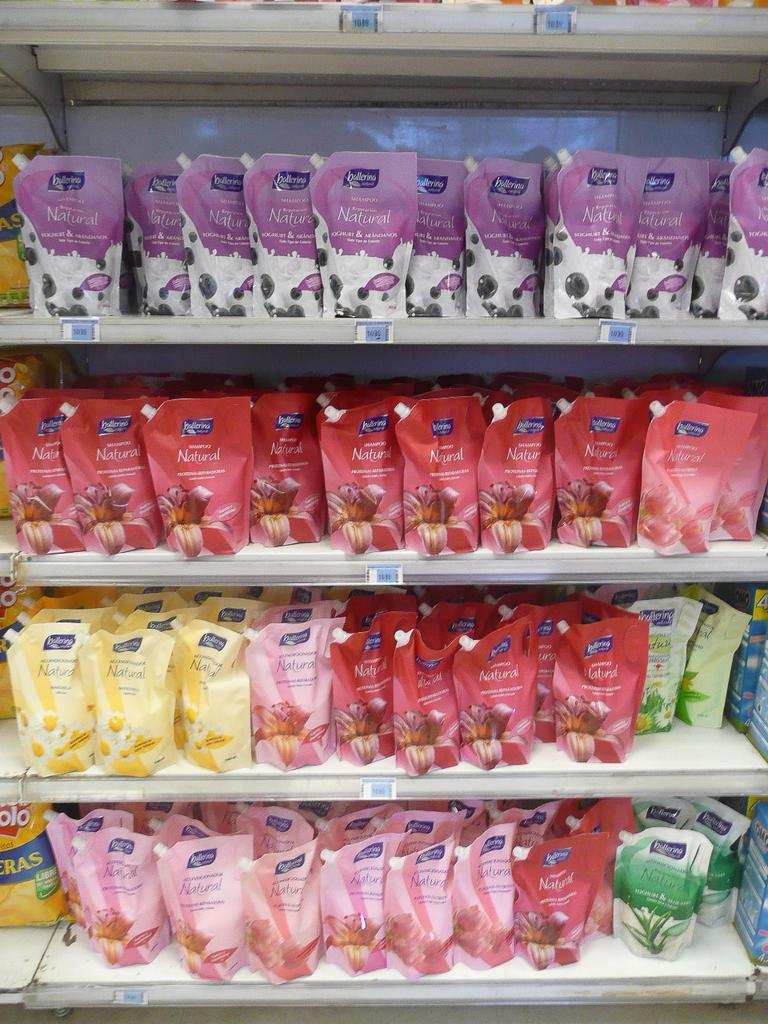<image>
Write a terse but informative summary of the picture. Several shelves of Ballarina brand packages in a variety of types. 